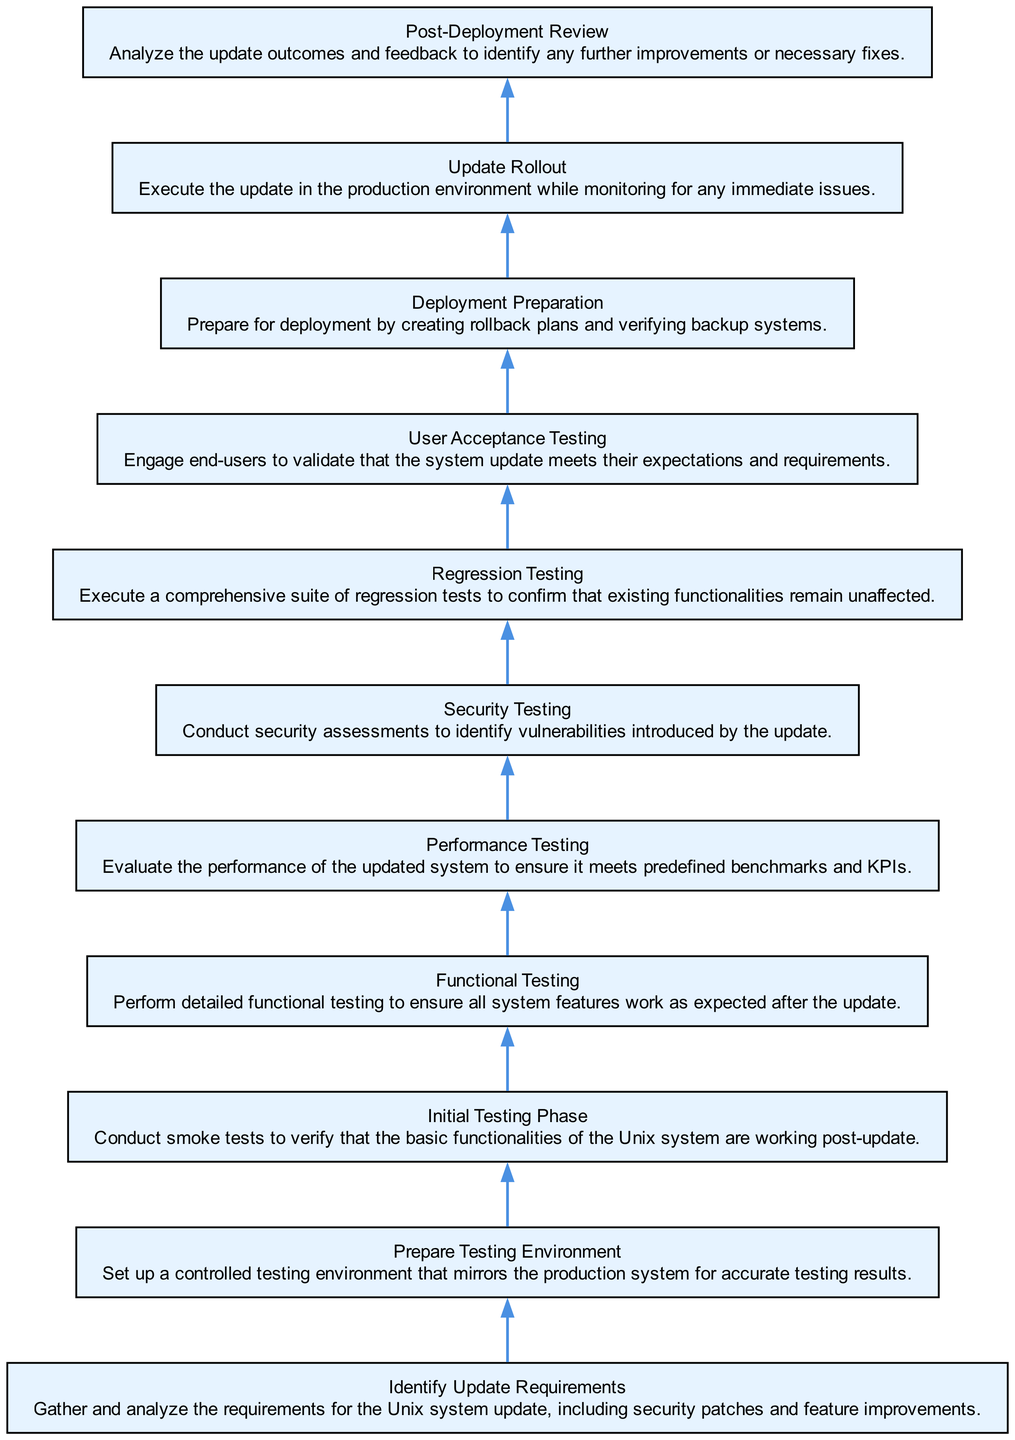What is the last phase in the Quality Assurance Process? The last phase in the diagram is labeled "Post-Deployment Review." This can be verified by looking at the bottommost node in the flow, which represents the final phase after the update rollout.
Answer: Post-Deployment Review How many testing phases are outlined in the diagram? The diagram includes several testing-related nodes: Initial Testing Phase, Functional Testing, Performance Testing, Security Testing, Regression Testing, and User Acceptance Testing. Counting these gives a total of six distinct testing phases.
Answer: Six Which phase follows "Security Testing"? By tracing the flow of the diagram, we see that "Security Testing" connects to "Regression Testing" as the next phase in the process. This connection is represented by an edge extending from the security phase node to the regression phase node.
Answer: Regression Testing What type of testing is performed immediately after "Initial Testing Phase"? The diagram indicates that "Functional Testing" directly follows "Initial Testing Phase," as represented by the edge connecting both of these nodes in the flow.
Answer: Functional Testing How many edges connect testing phases to deployment phases? In examining the flow of the diagram, we can identify edges that connect the last testing phase, "User Acceptance Testing", to the first deployment phase, "Deployment Preparation", thus yielding an answer of one direct connection from testing to deployment.
Answer: One 